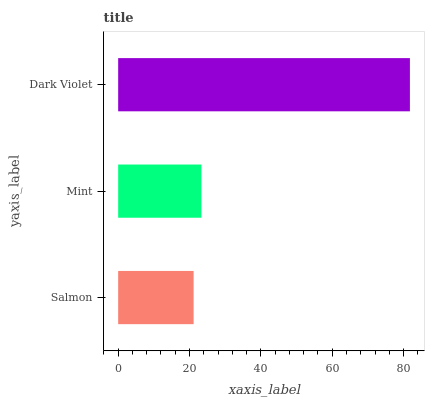Is Salmon the minimum?
Answer yes or no. Yes. Is Dark Violet the maximum?
Answer yes or no. Yes. Is Mint the minimum?
Answer yes or no. No. Is Mint the maximum?
Answer yes or no. No. Is Mint greater than Salmon?
Answer yes or no. Yes. Is Salmon less than Mint?
Answer yes or no. Yes. Is Salmon greater than Mint?
Answer yes or no. No. Is Mint less than Salmon?
Answer yes or no. No. Is Mint the high median?
Answer yes or no. Yes. Is Mint the low median?
Answer yes or no. Yes. Is Salmon the high median?
Answer yes or no. No. Is Salmon the low median?
Answer yes or no. No. 